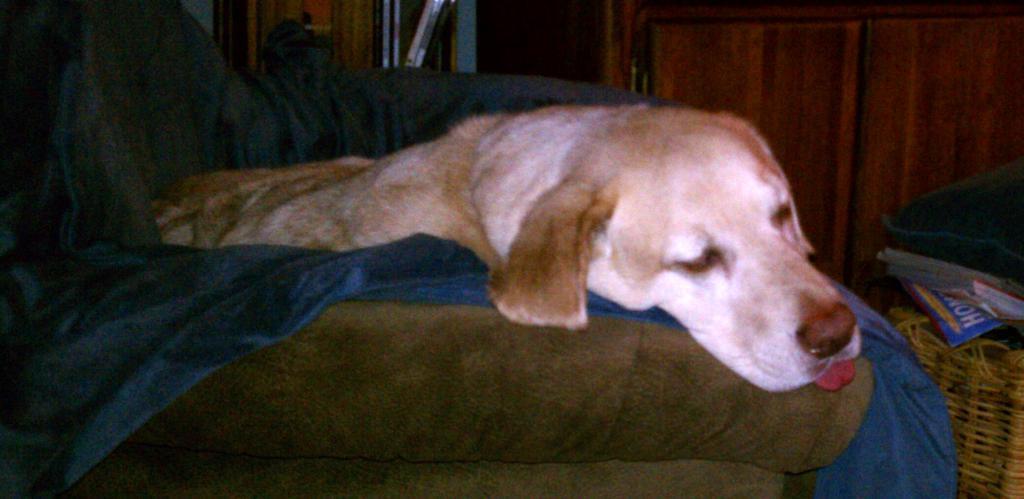Please provide a concise description of this image. In this image we can see a dog, there is a blanket, beside there is a basket and some objects on it. 